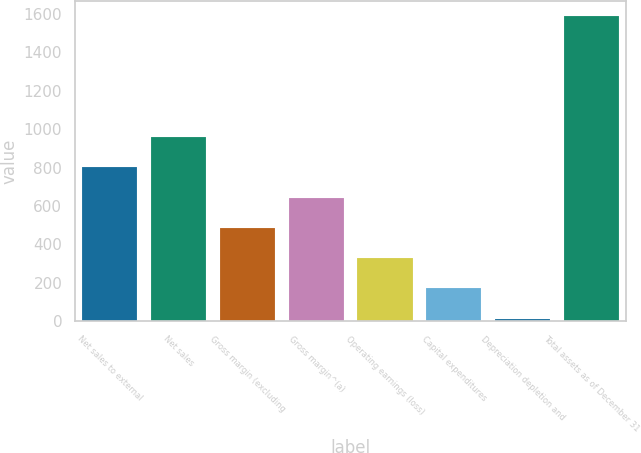Convert chart. <chart><loc_0><loc_0><loc_500><loc_500><bar_chart><fcel>Net sales to external<fcel>Net sales<fcel>Gross margin (excluding<fcel>Gross margin^(a)<fcel>Operating earnings (loss)<fcel>Capital expenditures<fcel>Depreciation depletion and<fcel>Total assets as of December 31<nl><fcel>800.25<fcel>957.62<fcel>485.51<fcel>642.88<fcel>328.14<fcel>170.77<fcel>13.4<fcel>1587.1<nl></chart> 